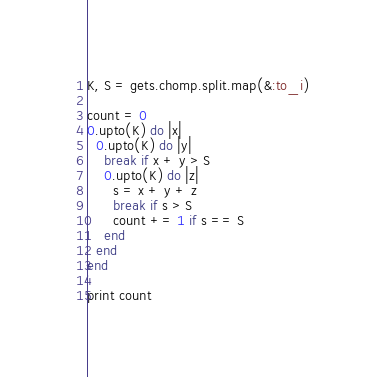Convert code to text. <code><loc_0><loc_0><loc_500><loc_500><_Ruby_>K, S = gets.chomp.split.map(&:to_i)

count = 0
0.upto(K) do |x|
  0.upto(K) do |y|
    break if x + y > S
    0.upto(K) do |z|
      s = x + y + z
      break if s > S
      count += 1 if s == S
    end
  end
end

print count</code> 